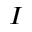<formula> <loc_0><loc_0><loc_500><loc_500>I</formula> 